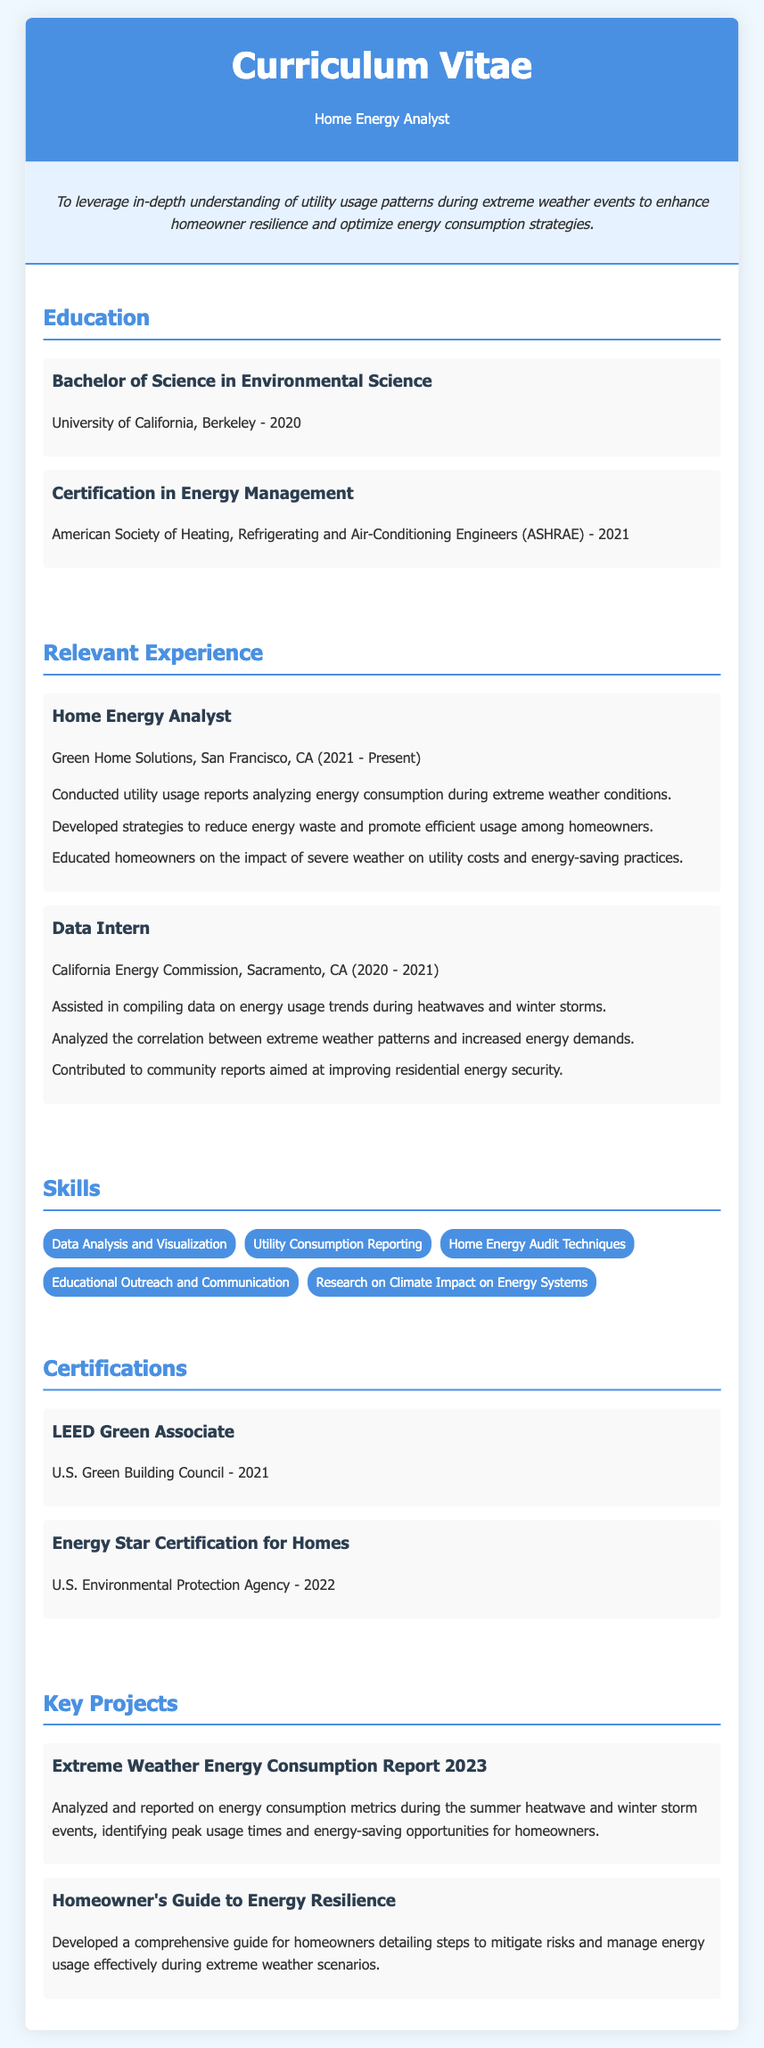What is the highest degree obtained? The highest degree noted in the document is a Bachelor of Science in Environmental Science.
Answer: Bachelor of Science in Environmental Science In which year was the Energy Management certification obtained? The document states that the Energy Management certification was obtained in 2021.
Answer: 2021 Who is the current employer listed for the Home Energy Analyst position? The current employer for the Home Energy Analyst position is Green Home Solutions.
Answer: Green Home Solutions What is a key project related to extreme weather reported in the document? The document details a project titled "Extreme Weather Energy Consumption Report 2023."
Answer: Extreme Weather Energy Consumption Report 2023 Which skill mentioned relates to homeowner education? The skill that relates to homeowner education is Educational Outreach and Communication.
Answer: Educational Outreach and Communication How long did the Data Intern work at the California Energy Commission? The duration of the Data Intern position is from 2020 to 2021, indicating one year.
Answer: 1 year What type of certification is the "LEED Green Associate"? This certification is specifically noted as a green building certification.
Answer: Green building certification What city is associated with the current job of the individual? The individual works in San Francisco, CA.
Answer: San Francisco, CA What is the focus of the "Homeowner's Guide to Energy Resilience"? The guide focuses on steps for homeowners to mitigate risks during extreme weather.
Answer: Mitigate risks during extreme weather 